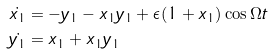Convert formula to latex. <formula><loc_0><loc_0><loc_500><loc_500>\dot { x _ { 1 } } & = - y _ { 1 } - x _ { 1 } y _ { 1 } + \epsilon ( 1 + x _ { 1 } ) \cos { \Omega t } \\ \dot { y _ { 1 } } & = x _ { 1 } + x _ { 1 } y _ { 1 }</formula> 